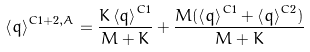Convert formula to latex. <formula><loc_0><loc_0><loc_500><loc_500>\left \langle q \right \rangle ^ { C 1 + 2 , A } = \frac { K \left \langle q \right \rangle ^ { C 1 } } { M + K } + \frac { M ( \left \langle q \right \rangle ^ { C 1 } + \left \langle q \right \rangle ^ { C 2 } ) } { M + K }</formula> 